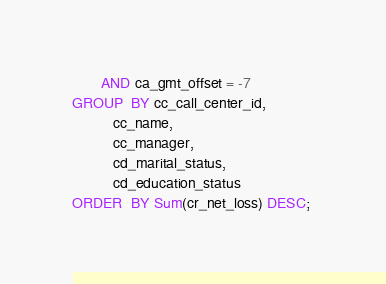<code> <loc_0><loc_0><loc_500><loc_500><_SQL_>       AND ca_gmt_offset = -7 
GROUP  BY cc_call_center_id, 
          cc_name, 
          cc_manager, 
          cd_marital_status, 
          cd_education_status 
ORDER  BY Sum(cr_net_loss) DESC; 
</code> 